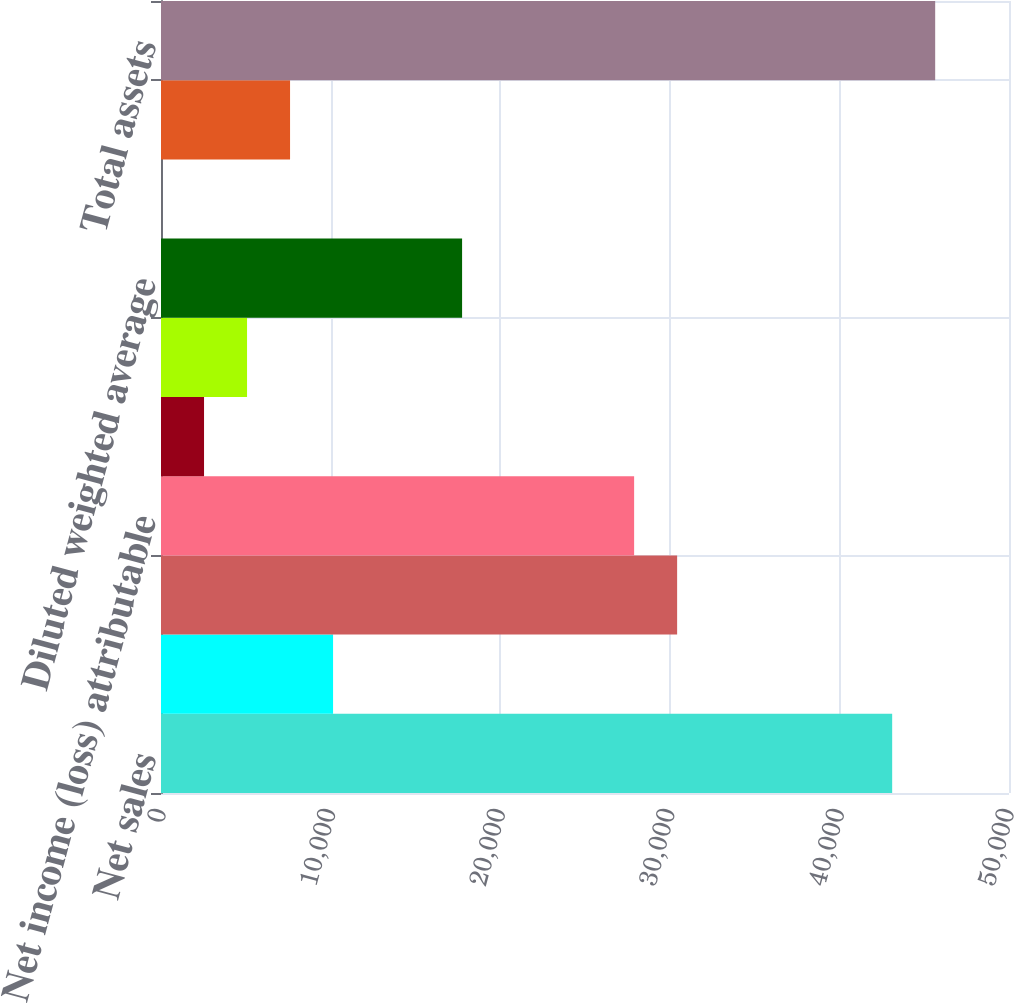Convert chart to OTSL. <chart><loc_0><loc_0><loc_500><loc_500><bar_chart><fcel>Net sales<fcel>Restructuring and other costs<fcel>Income from continuing<fcel>Net income (loss) attributable<fcel>Diluted earnings per share<fcel>Diluted earnings (loss) per<fcel>Diluted weighted average<fcel>Dividends paid per common<fcel>Book value per common share<fcel>Total assets<nl><fcel>43111.7<fcel>10145.2<fcel>30432.3<fcel>27896.4<fcel>2537.6<fcel>5073.48<fcel>17752.9<fcel>1.72<fcel>7609.36<fcel>45647.6<nl></chart> 